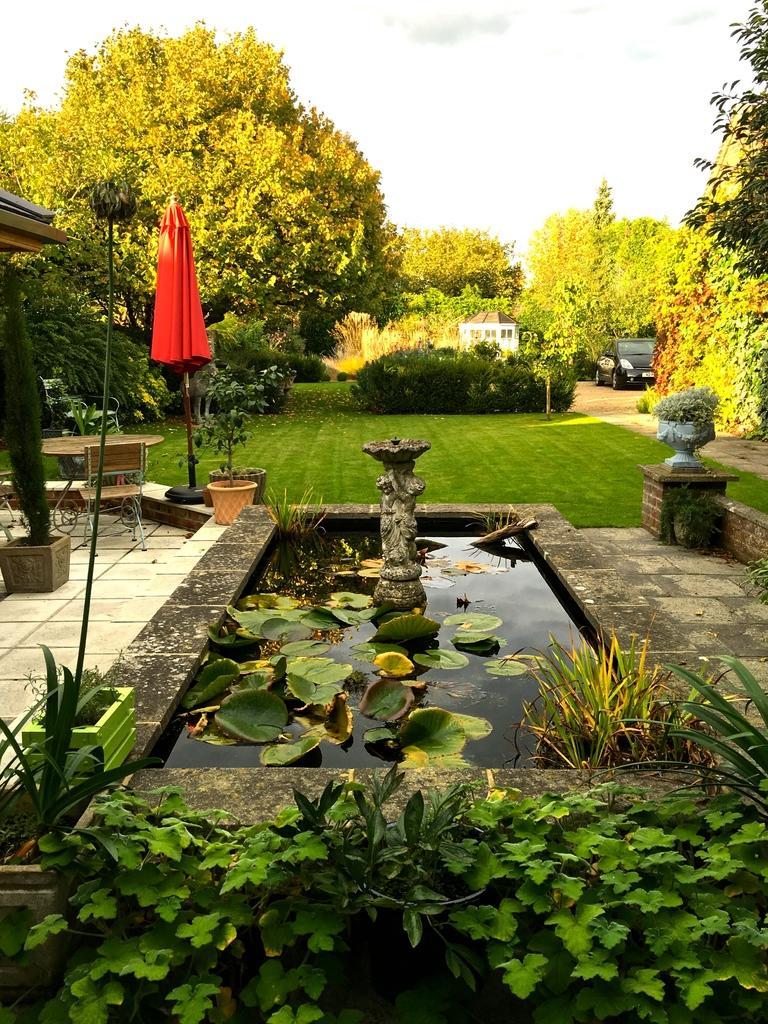Describe this image in one or two sentences. In this image we can see the leaves and a fountain. And there are potted plants, chairs, table, stick with cloth and wall. We can see a vehicle on the ground. And there are trees, grass, plants and the sky. 